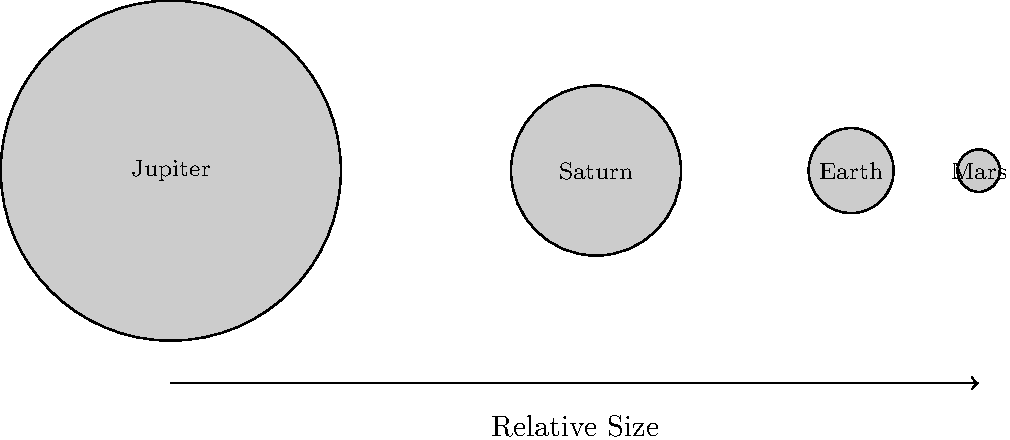In your role overseeing the health needs of a remote community, you receive educational materials about space exploration. One diagram shows the relative sizes of planets. Based on the image, approximately how many times larger is Jupiter's diameter compared to Earth's? To determine how many times larger Jupiter's diameter is compared to Earth's, we need to follow these steps:

1. Observe the relative sizes of the planets in the diagram.
2. Compare the diameters of Jupiter and Earth visually.
3. Estimate the ratio between their diameters.

In the diagram:
- Jupiter's diameter is represented by a circle with a radius of 2 units.
- Earth's diameter is represented by a circle with a radius of 0.5 units.

To find the ratio:
1. Jupiter's diameter = 2 * 2 = 4 units
2. Earth's diameter = 2 * 0.5 = 1 unit
3. Ratio = Jupiter's diameter / Earth's diameter = 4 / 1 = 4

Therefore, Jupiter's diameter is approximately 4 times larger than Earth's diameter.

This simplified representation helps in understanding the vast scale differences in our solar system, which could be relevant when discussing the challenges of space exploration and its potential impact on health research for remote communities.
Answer: 4 times 